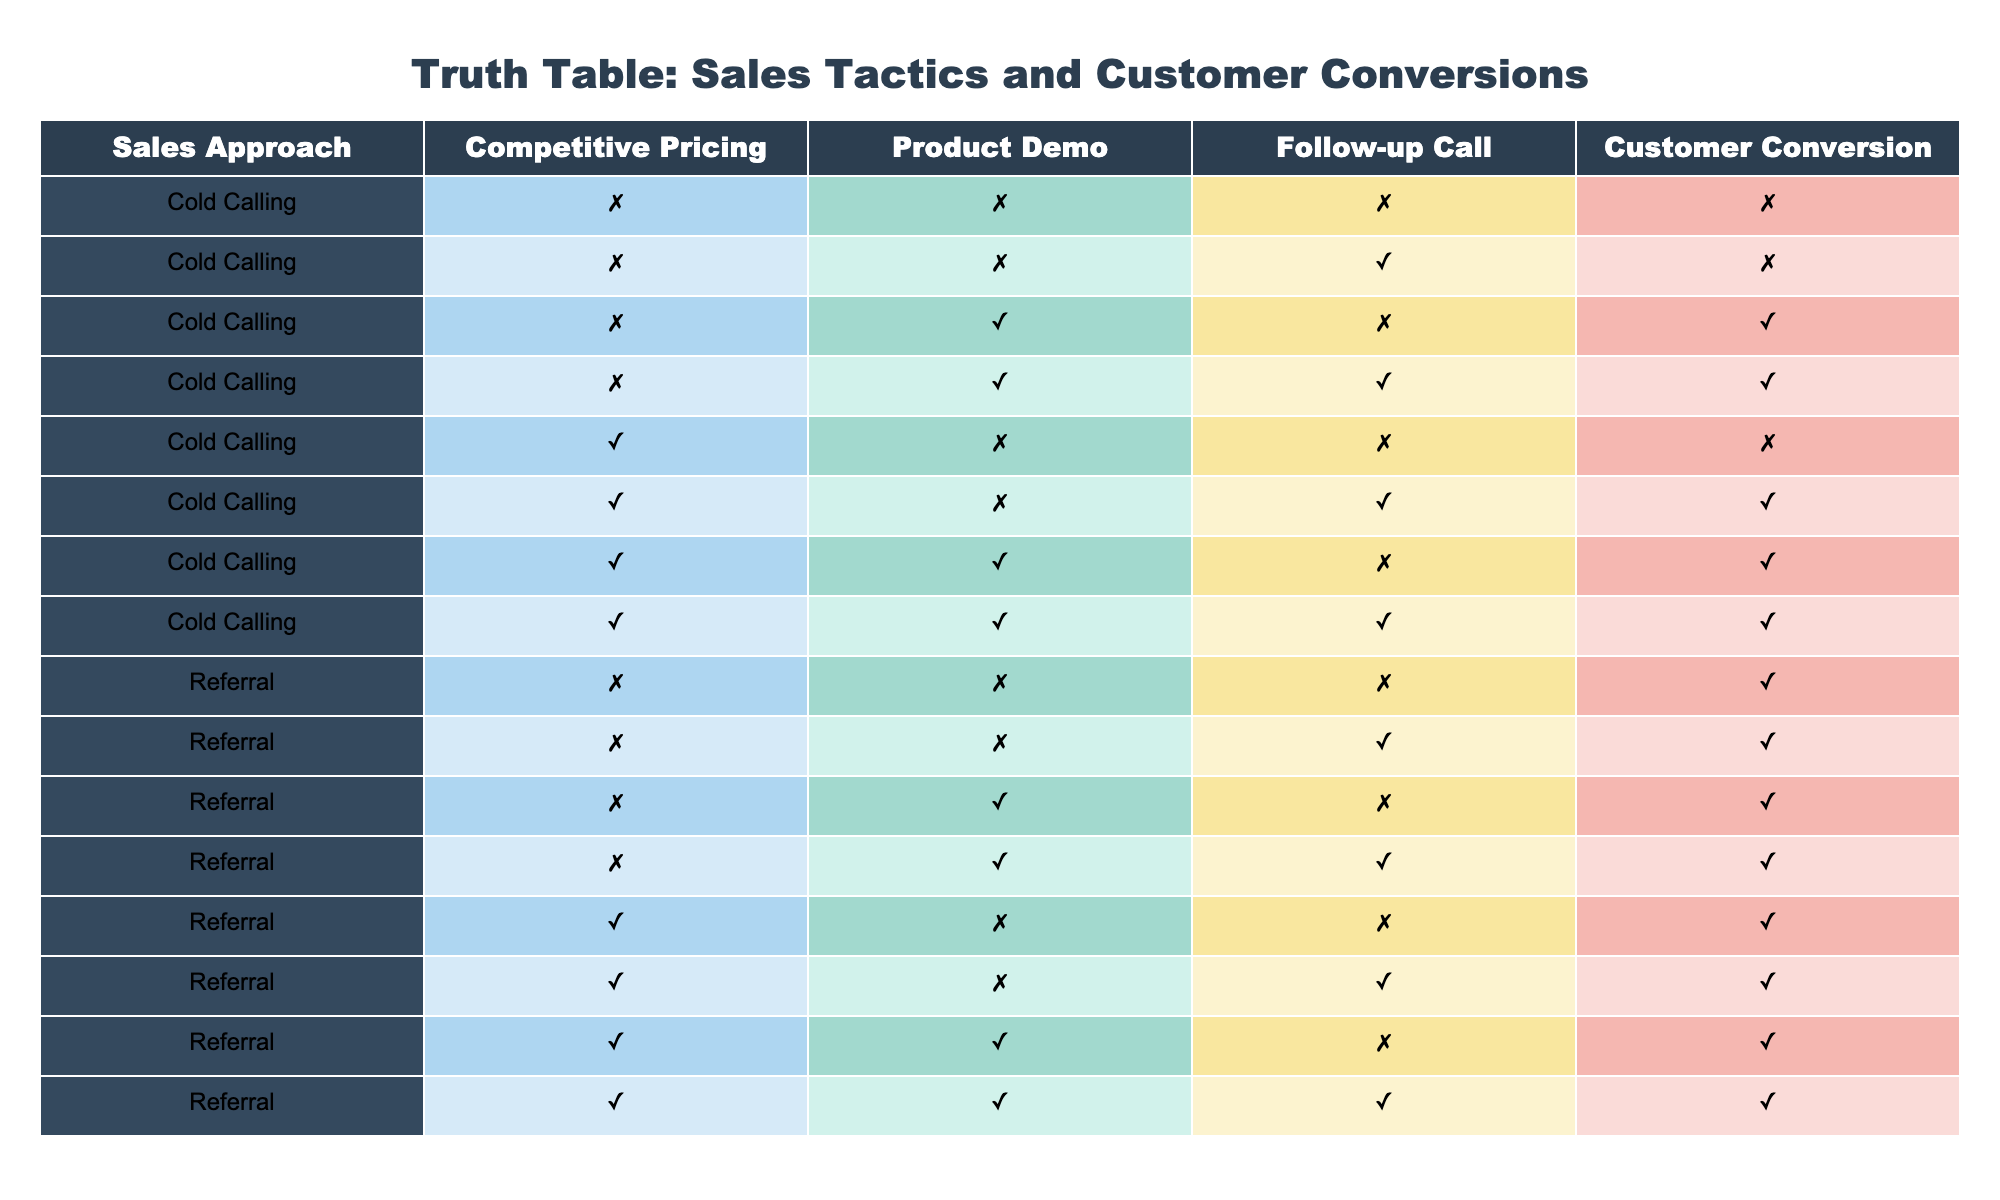What's the customer conversion rate when follow-up calls are made? To find the customer conversion rate with follow-up calls, we look at the rows where "Follow-up Call" is TRUE. There are 6 relevant cases: 1, 1, 1, 1, 1, and 0. Out of these, 5 cases (where customer conversion is TRUE) out of 6 total cases gives a conversion rate of 5/6, which is approximately 83.33%.
Answer: Approximately 83.33% How many sales approaches result in customer conversion? By counting the rows where "Customer Conversion" is TRUE, we find there are 8 instances (4 from "Cold Calling" and 4 from "Referral"). The total number of sales approaches that achieve conversion is 8.
Answer: 8 What is the total number of cases with product demos that lead to customer conversion? We examine rows where "Product Demo" is TRUE. There are 4 cases that lead to customer conversion (including "Cold Calling" and "Referral"). Therefore, the total number of cases with product demos that lead to customer conversion is 4.
Answer: 4 Do all instances of competitive pricing lead to customer conversion? Looking at the rows where "Competitive Pricing" is TRUE, there are 5 instances, but only 2 of those lead to customer conversion. So, not all instances with competitive pricing lead to conversion.
Answer: No How does the presence of product demos and follow-up calls affect customer conversion in cold calling? Analyzing cold calling cases: with no product demo or follow-up call, conversion is 0; with demo only, it’s 1; with follow-up call only, it’s 0; and with both, it’s 1. This shows that product demos alone improve conversion and that follow-up calls in combination also contribute positively.
Answer: Product demos improve conversion in cold calling 